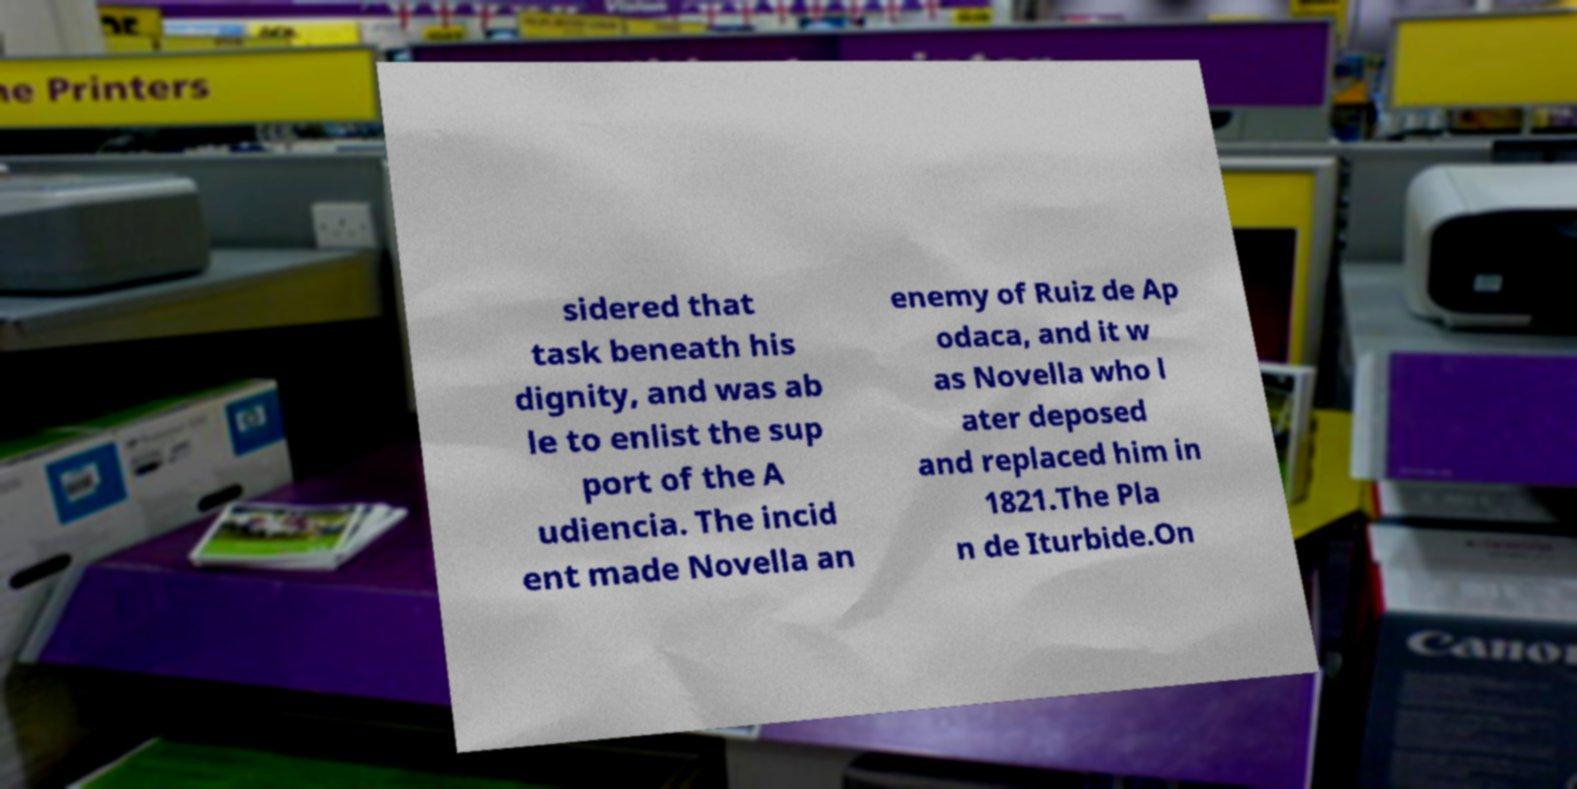Please identify and transcribe the text found in this image. sidered that task beneath his dignity, and was ab le to enlist the sup port of the A udiencia. The incid ent made Novella an enemy of Ruiz de Ap odaca, and it w as Novella who l ater deposed and replaced him in 1821.The Pla n de Iturbide.On 